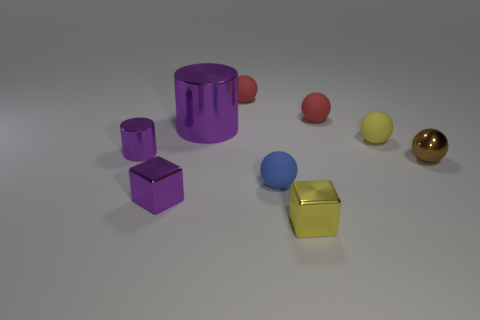Subtract 3 balls. How many balls are left? 2 Subtract all gray blocks. How many red spheres are left? 2 Subtract all brown balls. How many balls are left? 4 Subtract all tiny yellow balls. How many balls are left? 4 Subtract all blue spheres. Subtract all blue cylinders. How many spheres are left? 4 Add 1 small brown metallic balls. How many objects exist? 10 Subtract all cubes. How many objects are left? 7 Subtract 0 red cubes. How many objects are left? 9 Subtract all yellow matte spheres. Subtract all small purple metallic cylinders. How many objects are left? 7 Add 4 red matte objects. How many red matte objects are left? 6 